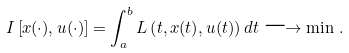<formula> <loc_0><loc_0><loc_500><loc_500>I \left [ x ( \cdot ) , u ( \cdot ) \right ] = \int _ { a } ^ { b } L \left ( t , x ( t ) , u ( t ) \right ) d t \longrightarrow \min \, .</formula> 